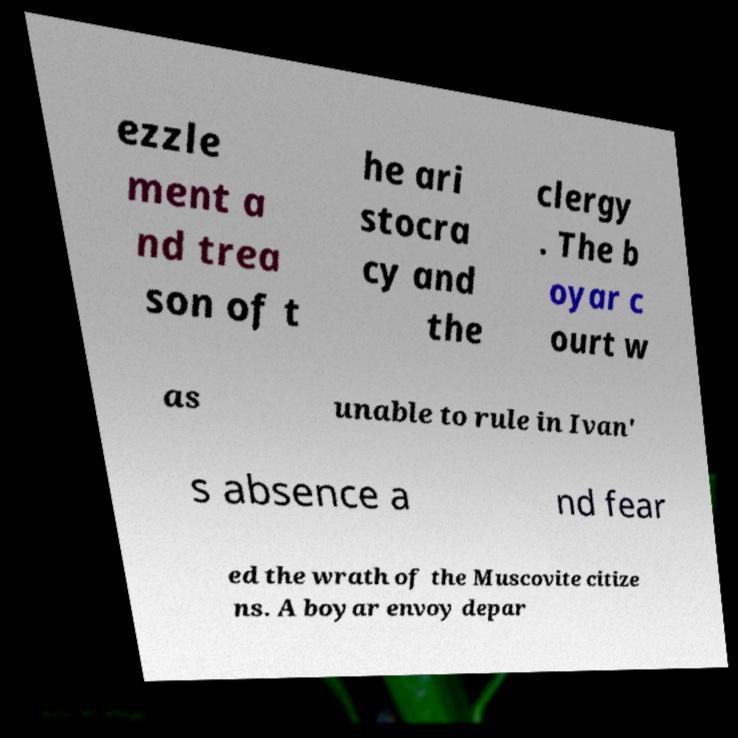There's text embedded in this image that I need extracted. Can you transcribe it verbatim? ezzle ment a nd trea son of t he ari stocra cy and the clergy . The b oyar c ourt w as unable to rule in Ivan' s absence a nd fear ed the wrath of the Muscovite citize ns. A boyar envoy depar 